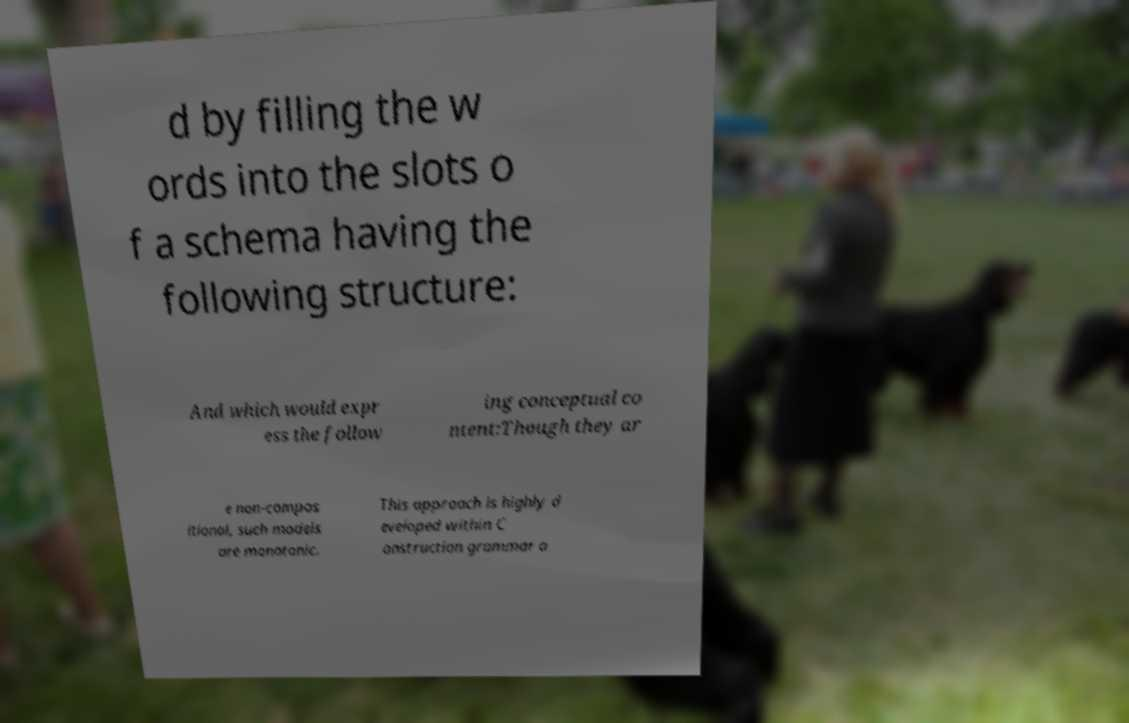Can you read and provide the text displayed in the image?This photo seems to have some interesting text. Can you extract and type it out for me? d by filling the w ords into the slots o f a schema having the following structure: And which would expr ess the follow ing conceptual co ntent:Though they ar e non-compos itional, such models are monotonic. This approach is highly d eveloped within C onstruction grammar a 